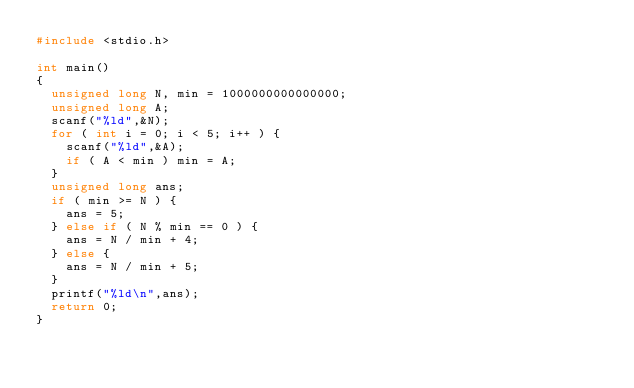Convert code to text. <code><loc_0><loc_0><loc_500><loc_500><_C_>#include <stdio.h>

int main()
{
  unsigned long N, min = 1000000000000000;
  unsigned long A;
  scanf("%ld",&N);
  for ( int i = 0; i < 5; i++ ) {
    scanf("%ld",&A);
    if ( A < min ) min = A;
  }
  unsigned long ans;
  if ( min >= N ) {
    ans = 5;
  } else if ( N % min == 0 ) {
    ans = N / min + 4;
  } else {
    ans = N / min + 5;
  }
  printf("%ld\n",ans);
  return 0;
}</code> 